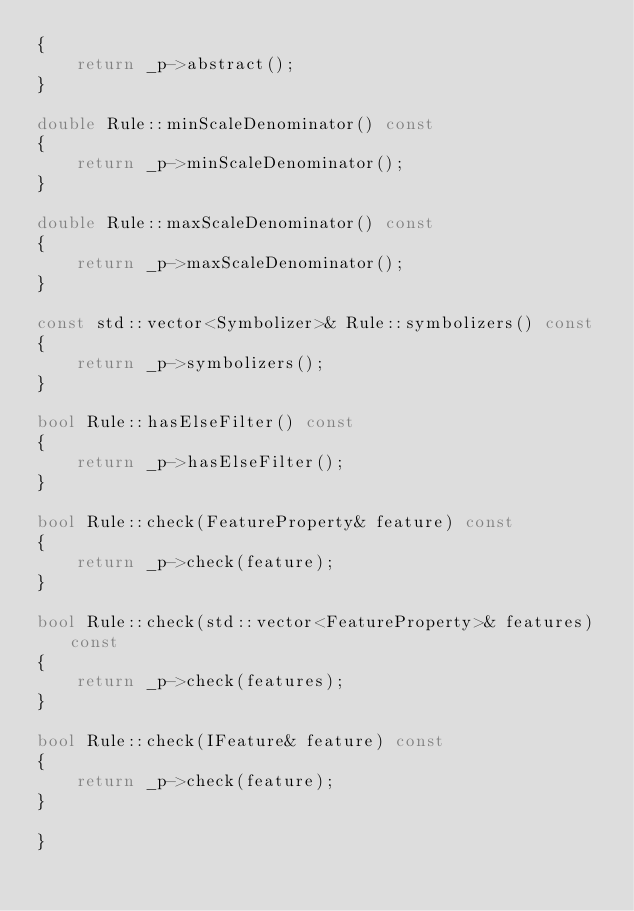<code> <loc_0><loc_0><loc_500><loc_500><_C++_>{
    return _p->abstract();
}

double Rule::minScaleDenominator() const
{
    return _p->minScaleDenominator();
}

double Rule::maxScaleDenominator() const
{
    return _p->maxScaleDenominator();
}

const std::vector<Symbolizer>& Rule::symbolizers() const
{
    return _p->symbolizers();
}

bool Rule::hasElseFilter() const
{
    return _p->hasElseFilter();
}

bool Rule::check(FeatureProperty& feature) const
{
    return _p->check(feature);
}

bool Rule::check(std::vector<FeatureProperty>& features) const
{
    return _p->check(features);
}

bool Rule::check(IFeature& feature) const
{
    return _p->check(feature);
}
  
}</code> 